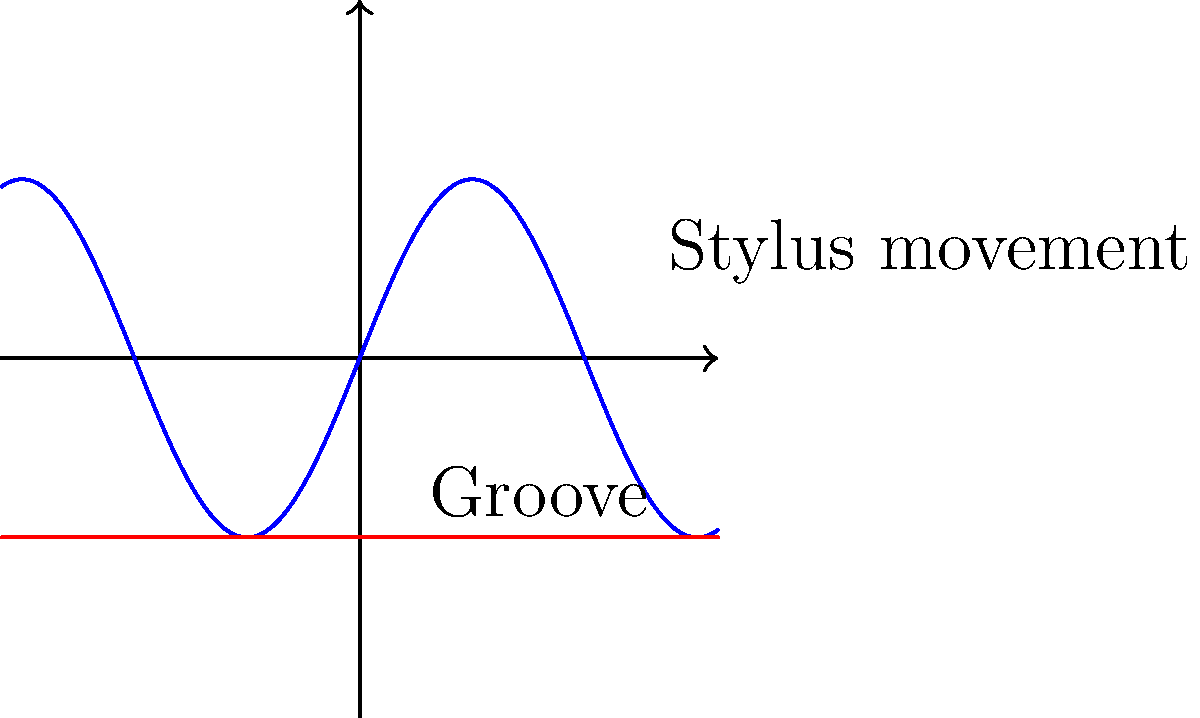As a DJ with a classical music background, you understand the importance of sound quality. When playing a vinyl record, the stylus follows the groove's undulations. If the frequency of these undulations is 1000 Hz and the groove's peak-to-peak amplitude is 10 micrometers, what is the maximum velocity of the stylus perpendicular to the record surface? Let's approach this step-by-step:

1) The stylus movement can be modeled as simple harmonic motion. The displacement y as a function of time t is given by:

   $y(t) = A \sin(2\pi ft)$

   where A is the amplitude and f is the frequency.

2) The peak-to-peak amplitude is 10 μm, so the amplitude A is half of this:
   
   $A = 5 \times 10^{-6}$ m

3) The velocity v is the derivative of displacement with respect to time:

   $v(t) = \frac{dy}{dt} = 2\pi f A \cos(2\pi ft)$

4) The maximum velocity occurs when $\cos(2\pi ft) = 1$, so:

   $v_{max} = 2\pi f A$

5) Substituting our values:

   $v_{max} = 2\pi (1000 \text{ Hz}) (5 \times 10^{-6} \text{ m})$

6) Calculate:

   $v_{max} = 10\pi \times 10^{-3} \text{ m/s} \approx 0.0314 \text{ m/s}$

This velocity is crucial for understanding the high-frequency response and potential distortion in vinyl playback, which is essential knowledge for a DJ with classical training.
Answer: 0.0314 m/s 